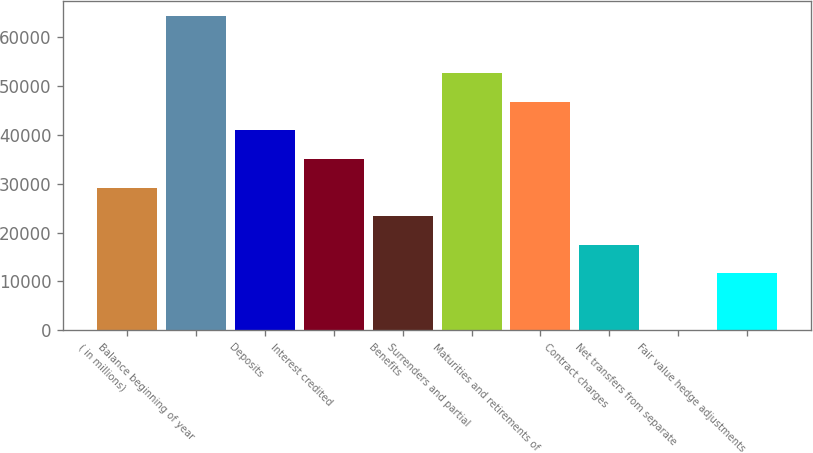<chart> <loc_0><loc_0><loc_500><loc_500><bar_chart><fcel>( in millions)<fcel>Balance beginning of year<fcel>Deposits<fcel>Interest credited<fcel>Benefits<fcel>Surrenders and partial<fcel>Maturities and retirements of<fcel>Contract charges<fcel>Net transfers from separate<fcel>Fair value hedge adjustments<nl><fcel>29212<fcel>64253.2<fcel>40892.4<fcel>35052.2<fcel>23371.8<fcel>52572.8<fcel>46732.6<fcel>17531.6<fcel>11<fcel>11691.4<nl></chart> 